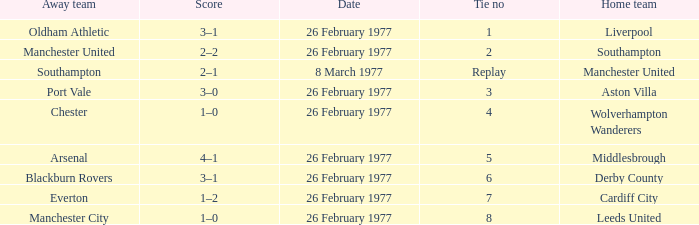Parse the table in full. {'header': ['Away team', 'Score', 'Date', 'Tie no', 'Home team'], 'rows': [['Oldham Athletic', '3–1', '26 February 1977', '1', 'Liverpool'], ['Manchester United', '2–2', '26 February 1977', '2', 'Southampton'], ['Southampton', '2–1', '8 March 1977', 'Replay', 'Manchester United'], ['Port Vale', '3–0', '26 February 1977', '3', 'Aston Villa'], ['Chester', '1–0', '26 February 1977', '4', 'Wolverhampton Wanderers'], ['Arsenal', '4–1', '26 February 1977', '5', 'Middlesbrough'], ['Blackburn Rovers', '3–1', '26 February 1977', '6', 'Derby County'], ['Everton', '1–2', '26 February 1977', '7', 'Cardiff City'], ['Manchester City', '1–0', '26 February 1977', '8', 'Leeds United']]} What's the score when the tie number was replay? 2–1. 